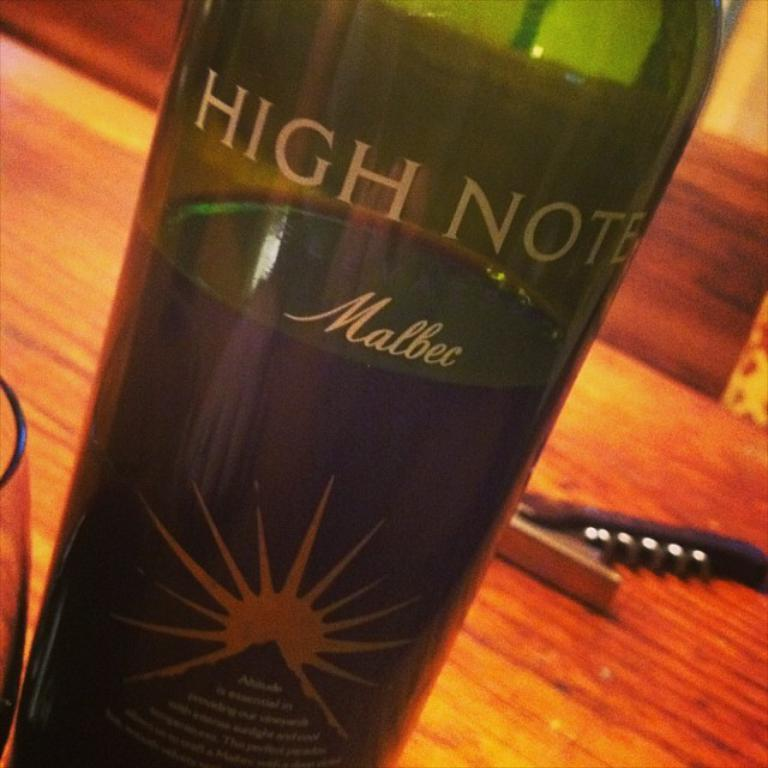What is the main object in the image? There is a wine bottle in the image. Where is the wine bottle located? The wine bottle is on a table. What type of club is being used to adjust the level of the wine bottle in the image? There is no club or adjustment being made to the wine bottle in the image; it is simply sitting on the table. 